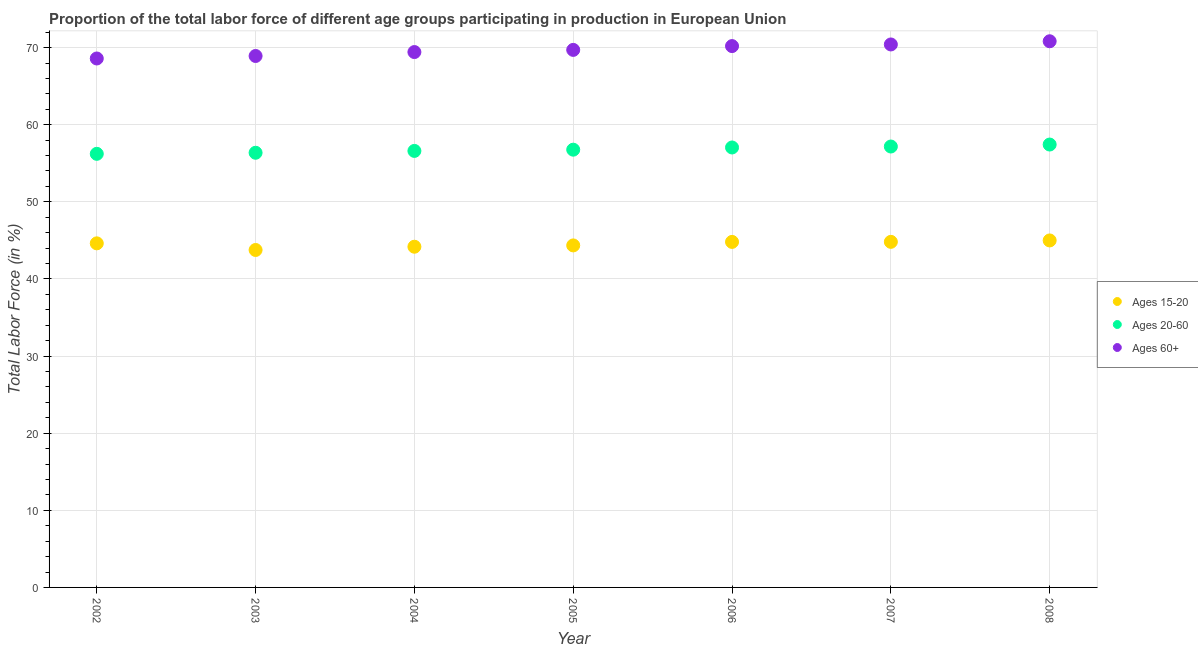What is the percentage of labor force above age 60 in 2003?
Your answer should be compact. 68.91. Across all years, what is the maximum percentage of labor force within the age group 20-60?
Your response must be concise. 57.43. Across all years, what is the minimum percentage of labor force within the age group 20-60?
Your answer should be compact. 56.23. What is the total percentage of labor force within the age group 15-20 in the graph?
Make the answer very short. 311.52. What is the difference between the percentage of labor force above age 60 in 2006 and that in 2008?
Your answer should be compact. -0.63. What is the difference between the percentage of labor force above age 60 in 2008 and the percentage of labor force within the age group 15-20 in 2004?
Offer a terse response. 26.64. What is the average percentage of labor force above age 60 per year?
Offer a terse response. 69.72. In the year 2003, what is the difference between the percentage of labor force above age 60 and percentage of labor force within the age group 15-20?
Your response must be concise. 25.16. In how many years, is the percentage of labor force within the age group 20-60 greater than 22 %?
Your answer should be very brief. 7. What is the ratio of the percentage of labor force within the age group 20-60 in 2002 to that in 2006?
Your answer should be very brief. 0.99. Is the difference between the percentage of labor force within the age group 15-20 in 2002 and 2004 greater than the difference between the percentage of labor force above age 60 in 2002 and 2004?
Provide a short and direct response. Yes. What is the difference between the highest and the second highest percentage of labor force above age 60?
Give a very brief answer. 0.41. What is the difference between the highest and the lowest percentage of labor force within the age group 20-60?
Your answer should be compact. 1.21. In how many years, is the percentage of labor force within the age group 15-20 greater than the average percentage of labor force within the age group 15-20 taken over all years?
Your answer should be compact. 4. Is the sum of the percentage of labor force above age 60 in 2007 and 2008 greater than the maximum percentage of labor force within the age group 15-20 across all years?
Make the answer very short. Yes. Does the percentage of labor force above age 60 monotonically increase over the years?
Give a very brief answer. Yes. Are the values on the major ticks of Y-axis written in scientific E-notation?
Offer a very short reply. No. What is the title of the graph?
Make the answer very short. Proportion of the total labor force of different age groups participating in production in European Union. Does "Negligence towards kids" appear as one of the legend labels in the graph?
Make the answer very short. No. What is the label or title of the Y-axis?
Give a very brief answer. Total Labor Force (in %). What is the Total Labor Force (in %) in Ages 15-20 in 2002?
Your answer should be very brief. 44.62. What is the Total Labor Force (in %) in Ages 20-60 in 2002?
Your answer should be very brief. 56.23. What is the Total Labor Force (in %) of Ages 60+ in 2002?
Your answer should be compact. 68.59. What is the Total Labor Force (in %) of Ages 15-20 in 2003?
Offer a very short reply. 43.76. What is the Total Labor Force (in %) of Ages 20-60 in 2003?
Provide a short and direct response. 56.36. What is the Total Labor Force (in %) of Ages 60+ in 2003?
Provide a short and direct response. 68.91. What is the Total Labor Force (in %) in Ages 15-20 in 2004?
Provide a short and direct response. 44.18. What is the Total Labor Force (in %) of Ages 20-60 in 2004?
Your answer should be compact. 56.6. What is the Total Labor Force (in %) of Ages 60+ in 2004?
Your response must be concise. 69.42. What is the Total Labor Force (in %) in Ages 15-20 in 2005?
Your response must be concise. 44.35. What is the Total Labor Force (in %) in Ages 20-60 in 2005?
Keep it short and to the point. 56.76. What is the Total Labor Force (in %) in Ages 60+ in 2005?
Ensure brevity in your answer.  69.7. What is the Total Labor Force (in %) in Ages 15-20 in 2006?
Provide a succinct answer. 44.81. What is the Total Labor Force (in %) in Ages 20-60 in 2006?
Your response must be concise. 57.05. What is the Total Labor Force (in %) in Ages 60+ in 2006?
Your answer should be very brief. 70.2. What is the Total Labor Force (in %) in Ages 15-20 in 2007?
Keep it short and to the point. 44.81. What is the Total Labor Force (in %) in Ages 20-60 in 2007?
Provide a short and direct response. 57.17. What is the Total Labor Force (in %) in Ages 60+ in 2007?
Make the answer very short. 70.41. What is the Total Labor Force (in %) in Ages 15-20 in 2008?
Your answer should be compact. 44.99. What is the Total Labor Force (in %) of Ages 20-60 in 2008?
Keep it short and to the point. 57.43. What is the Total Labor Force (in %) in Ages 60+ in 2008?
Ensure brevity in your answer.  70.82. Across all years, what is the maximum Total Labor Force (in %) in Ages 15-20?
Give a very brief answer. 44.99. Across all years, what is the maximum Total Labor Force (in %) in Ages 20-60?
Make the answer very short. 57.43. Across all years, what is the maximum Total Labor Force (in %) in Ages 60+?
Give a very brief answer. 70.82. Across all years, what is the minimum Total Labor Force (in %) of Ages 15-20?
Make the answer very short. 43.76. Across all years, what is the minimum Total Labor Force (in %) of Ages 20-60?
Your response must be concise. 56.23. Across all years, what is the minimum Total Labor Force (in %) in Ages 60+?
Provide a short and direct response. 68.59. What is the total Total Labor Force (in %) of Ages 15-20 in the graph?
Your answer should be very brief. 311.52. What is the total Total Labor Force (in %) of Ages 20-60 in the graph?
Offer a terse response. 397.61. What is the total Total Labor Force (in %) of Ages 60+ in the graph?
Your answer should be very brief. 488.06. What is the difference between the Total Labor Force (in %) of Ages 15-20 in 2002 and that in 2003?
Keep it short and to the point. 0.86. What is the difference between the Total Labor Force (in %) in Ages 20-60 in 2002 and that in 2003?
Your response must be concise. -0.14. What is the difference between the Total Labor Force (in %) in Ages 60+ in 2002 and that in 2003?
Offer a terse response. -0.32. What is the difference between the Total Labor Force (in %) of Ages 15-20 in 2002 and that in 2004?
Provide a succinct answer. 0.44. What is the difference between the Total Labor Force (in %) in Ages 20-60 in 2002 and that in 2004?
Offer a very short reply. -0.38. What is the difference between the Total Labor Force (in %) in Ages 60+ in 2002 and that in 2004?
Make the answer very short. -0.83. What is the difference between the Total Labor Force (in %) of Ages 15-20 in 2002 and that in 2005?
Provide a short and direct response. 0.27. What is the difference between the Total Labor Force (in %) of Ages 20-60 in 2002 and that in 2005?
Make the answer very short. -0.54. What is the difference between the Total Labor Force (in %) of Ages 60+ in 2002 and that in 2005?
Make the answer very short. -1.11. What is the difference between the Total Labor Force (in %) of Ages 15-20 in 2002 and that in 2006?
Keep it short and to the point. -0.19. What is the difference between the Total Labor Force (in %) of Ages 20-60 in 2002 and that in 2006?
Give a very brief answer. -0.82. What is the difference between the Total Labor Force (in %) in Ages 60+ in 2002 and that in 2006?
Ensure brevity in your answer.  -1.61. What is the difference between the Total Labor Force (in %) of Ages 15-20 in 2002 and that in 2007?
Your answer should be compact. -0.19. What is the difference between the Total Labor Force (in %) of Ages 20-60 in 2002 and that in 2007?
Make the answer very short. -0.95. What is the difference between the Total Labor Force (in %) of Ages 60+ in 2002 and that in 2007?
Your response must be concise. -1.82. What is the difference between the Total Labor Force (in %) in Ages 15-20 in 2002 and that in 2008?
Your answer should be compact. -0.38. What is the difference between the Total Labor Force (in %) in Ages 20-60 in 2002 and that in 2008?
Provide a succinct answer. -1.21. What is the difference between the Total Labor Force (in %) of Ages 60+ in 2002 and that in 2008?
Give a very brief answer. -2.23. What is the difference between the Total Labor Force (in %) in Ages 15-20 in 2003 and that in 2004?
Ensure brevity in your answer.  -0.42. What is the difference between the Total Labor Force (in %) of Ages 20-60 in 2003 and that in 2004?
Ensure brevity in your answer.  -0.24. What is the difference between the Total Labor Force (in %) in Ages 60+ in 2003 and that in 2004?
Give a very brief answer. -0.51. What is the difference between the Total Labor Force (in %) in Ages 15-20 in 2003 and that in 2005?
Make the answer very short. -0.59. What is the difference between the Total Labor Force (in %) of Ages 20-60 in 2003 and that in 2005?
Your answer should be compact. -0.4. What is the difference between the Total Labor Force (in %) of Ages 60+ in 2003 and that in 2005?
Ensure brevity in your answer.  -0.79. What is the difference between the Total Labor Force (in %) of Ages 15-20 in 2003 and that in 2006?
Give a very brief answer. -1.05. What is the difference between the Total Labor Force (in %) of Ages 20-60 in 2003 and that in 2006?
Make the answer very short. -0.68. What is the difference between the Total Labor Force (in %) in Ages 60+ in 2003 and that in 2006?
Make the answer very short. -1.28. What is the difference between the Total Labor Force (in %) in Ages 15-20 in 2003 and that in 2007?
Provide a short and direct response. -1.05. What is the difference between the Total Labor Force (in %) in Ages 20-60 in 2003 and that in 2007?
Offer a very short reply. -0.81. What is the difference between the Total Labor Force (in %) in Ages 60+ in 2003 and that in 2007?
Provide a short and direct response. -1.5. What is the difference between the Total Labor Force (in %) in Ages 15-20 in 2003 and that in 2008?
Offer a terse response. -1.24. What is the difference between the Total Labor Force (in %) in Ages 20-60 in 2003 and that in 2008?
Provide a short and direct response. -1.07. What is the difference between the Total Labor Force (in %) of Ages 60+ in 2003 and that in 2008?
Offer a terse response. -1.91. What is the difference between the Total Labor Force (in %) in Ages 15-20 in 2004 and that in 2005?
Provide a short and direct response. -0.17. What is the difference between the Total Labor Force (in %) in Ages 20-60 in 2004 and that in 2005?
Your answer should be very brief. -0.16. What is the difference between the Total Labor Force (in %) in Ages 60+ in 2004 and that in 2005?
Give a very brief answer. -0.28. What is the difference between the Total Labor Force (in %) in Ages 15-20 in 2004 and that in 2006?
Your answer should be compact. -0.63. What is the difference between the Total Labor Force (in %) of Ages 20-60 in 2004 and that in 2006?
Keep it short and to the point. -0.45. What is the difference between the Total Labor Force (in %) of Ages 60+ in 2004 and that in 2006?
Offer a terse response. -0.77. What is the difference between the Total Labor Force (in %) in Ages 15-20 in 2004 and that in 2007?
Give a very brief answer. -0.63. What is the difference between the Total Labor Force (in %) in Ages 20-60 in 2004 and that in 2007?
Offer a terse response. -0.57. What is the difference between the Total Labor Force (in %) in Ages 60+ in 2004 and that in 2007?
Your response must be concise. -0.99. What is the difference between the Total Labor Force (in %) in Ages 15-20 in 2004 and that in 2008?
Give a very brief answer. -0.82. What is the difference between the Total Labor Force (in %) in Ages 20-60 in 2004 and that in 2008?
Make the answer very short. -0.83. What is the difference between the Total Labor Force (in %) in Ages 60+ in 2004 and that in 2008?
Provide a succinct answer. -1.4. What is the difference between the Total Labor Force (in %) in Ages 15-20 in 2005 and that in 2006?
Offer a terse response. -0.45. What is the difference between the Total Labor Force (in %) of Ages 20-60 in 2005 and that in 2006?
Your answer should be compact. -0.29. What is the difference between the Total Labor Force (in %) of Ages 60+ in 2005 and that in 2006?
Ensure brevity in your answer.  -0.49. What is the difference between the Total Labor Force (in %) of Ages 15-20 in 2005 and that in 2007?
Make the answer very short. -0.46. What is the difference between the Total Labor Force (in %) of Ages 20-60 in 2005 and that in 2007?
Keep it short and to the point. -0.41. What is the difference between the Total Labor Force (in %) in Ages 60+ in 2005 and that in 2007?
Provide a succinct answer. -0.71. What is the difference between the Total Labor Force (in %) in Ages 15-20 in 2005 and that in 2008?
Provide a short and direct response. -0.64. What is the difference between the Total Labor Force (in %) of Ages 20-60 in 2005 and that in 2008?
Offer a very short reply. -0.67. What is the difference between the Total Labor Force (in %) of Ages 60+ in 2005 and that in 2008?
Your response must be concise. -1.12. What is the difference between the Total Labor Force (in %) of Ages 15-20 in 2006 and that in 2007?
Offer a terse response. -0.01. What is the difference between the Total Labor Force (in %) in Ages 20-60 in 2006 and that in 2007?
Give a very brief answer. -0.12. What is the difference between the Total Labor Force (in %) of Ages 60+ in 2006 and that in 2007?
Offer a terse response. -0.21. What is the difference between the Total Labor Force (in %) in Ages 15-20 in 2006 and that in 2008?
Your response must be concise. -0.19. What is the difference between the Total Labor Force (in %) in Ages 20-60 in 2006 and that in 2008?
Offer a very short reply. -0.38. What is the difference between the Total Labor Force (in %) of Ages 60+ in 2006 and that in 2008?
Your response must be concise. -0.63. What is the difference between the Total Labor Force (in %) of Ages 15-20 in 2007 and that in 2008?
Your answer should be very brief. -0.18. What is the difference between the Total Labor Force (in %) in Ages 20-60 in 2007 and that in 2008?
Provide a succinct answer. -0.26. What is the difference between the Total Labor Force (in %) in Ages 60+ in 2007 and that in 2008?
Provide a succinct answer. -0.41. What is the difference between the Total Labor Force (in %) in Ages 15-20 in 2002 and the Total Labor Force (in %) in Ages 20-60 in 2003?
Provide a short and direct response. -11.75. What is the difference between the Total Labor Force (in %) in Ages 15-20 in 2002 and the Total Labor Force (in %) in Ages 60+ in 2003?
Ensure brevity in your answer.  -24.3. What is the difference between the Total Labor Force (in %) of Ages 20-60 in 2002 and the Total Labor Force (in %) of Ages 60+ in 2003?
Keep it short and to the point. -12.69. What is the difference between the Total Labor Force (in %) in Ages 15-20 in 2002 and the Total Labor Force (in %) in Ages 20-60 in 2004?
Your answer should be compact. -11.99. What is the difference between the Total Labor Force (in %) in Ages 15-20 in 2002 and the Total Labor Force (in %) in Ages 60+ in 2004?
Offer a very short reply. -24.8. What is the difference between the Total Labor Force (in %) of Ages 20-60 in 2002 and the Total Labor Force (in %) of Ages 60+ in 2004?
Make the answer very short. -13.2. What is the difference between the Total Labor Force (in %) of Ages 15-20 in 2002 and the Total Labor Force (in %) of Ages 20-60 in 2005?
Provide a succinct answer. -12.15. What is the difference between the Total Labor Force (in %) in Ages 15-20 in 2002 and the Total Labor Force (in %) in Ages 60+ in 2005?
Provide a succinct answer. -25.09. What is the difference between the Total Labor Force (in %) of Ages 20-60 in 2002 and the Total Labor Force (in %) of Ages 60+ in 2005?
Offer a terse response. -13.48. What is the difference between the Total Labor Force (in %) of Ages 15-20 in 2002 and the Total Labor Force (in %) of Ages 20-60 in 2006?
Give a very brief answer. -12.43. What is the difference between the Total Labor Force (in %) of Ages 15-20 in 2002 and the Total Labor Force (in %) of Ages 60+ in 2006?
Give a very brief answer. -25.58. What is the difference between the Total Labor Force (in %) of Ages 20-60 in 2002 and the Total Labor Force (in %) of Ages 60+ in 2006?
Make the answer very short. -13.97. What is the difference between the Total Labor Force (in %) in Ages 15-20 in 2002 and the Total Labor Force (in %) in Ages 20-60 in 2007?
Ensure brevity in your answer.  -12.56. What is the difference between the Total Labor Force (in %) in Ages 15-20 in 2002 and the Total Labor Force (in %) in Ages 60+ in 2007?
Offer a terse response. -25.79. What is the difference between the Total Labor Force (in %) in Ages 20-60 in 2002 and the Total Labor Force (in %) in Ages 60+ in 2007?
Keep it short and to the point. -14.18. What is the difference between the Total Labor Force (in %) in Ages 15-20 in 2002 and the Total Labor Force (in %) in Ages 20-60 in 2008?
Your answer should be very brief. -12.81. What is the difference between the Total Labor Force (in %) in Ages 15-20 in 2002 and the Total Labor Force (in %) in Ages 60+ in 2008?
Your answer should be compact. -26.21. What is the difference between the Total Labor Force (in %) in Ages 20-60 in 2002 and the Total Labor Force (in %) in Ages 60+ in 2008?
Offer a very short reply. -14.6. What is the difference between the Total Labor Force (in %) of Ages 15-20 in 2003 and the Total Labor Force (in %) of Ages 20-60 in 2004?
Your answer should be compact. -12.85. What is the difference between the Total Labor Force (in %) in Ages 15-20 in 2003 and the Total Labor Force (in %) in Ages 60+ in 2004?
Ensure brevity in your answer.  -25.67. What is the difference between the Total Labor Force (in %) in Ages 20-60 in 2003 and the Total Labor Force (in %) in Ages 60+ in 2004?
Ensure brevity in your answer.  -13.06. What is the difference between the Total Labor Force (in %) in Ages 15-20 in 2003 and the Total Labor Force (in %) in Ages 20-60 in 2005?
Your answer should be very brief. -13.01. What is the difference between the Total Labor Force (in %) in Ages 15-20 in 2003 and the Total Labor Force (in %) in Ages 60+ in 2005?
Your answer should be very brief. -25.95. What is the difference between the Total Labor Force (in %) in Ages 20-60 in 2003 and the Total Labor Force (in %) in Ages 60+ in 2005?
Keep it short and to the point. -13.34. What is the difference between the Total Labor Force (in %) in Ages 15-20 in 2003 and the Total Labor Force (in %) in Ages 20-60 in 2006?
Keep it short and to the point. -13.29. What is the difference between the Total Labor Force (in %) in Ages 15-20 in 2003 and the Total Labor Force (in %) in Ages 60+ in 2006?
Provide a succinct answer. -26.44. What is the difference between the Total Labor Force (in %) of Ages 20-60 in 2003 and the Total Labor Force (in %) of Ages 60+ in 2006?
Provide a succinct answer. -13.83. What is the difference between the Total Labor Force (in %) in Ages 15-20 in 2003 and the Total Labor Force (in %) in Ages 20-60 in 2007?
Your answer should be compact. -13.42. What is the difference between the Total Labor Force (in %) of Ages 15-20 in 2003 and the Total Labor Force (in %) of Ages 60+ in 2007?
Give a very brief answer. -26.65. What is the difference between the Total Labor Force (in %) of Ages 20-60 in 2003 and the Total Labor Force (in %) of Ages 60+ in 2007?
Your answer should be compact. -14.04. What is the difference between the Total Labor Force (in %) in Ages 15-20 in 2003 and the Total Labor Force (in %) in Ages 20-60 in 2008?
Provide a short and direct response. -13.67. What is the difference between the Total Labor Force (in %) in Ages 15-20 in 2003 and the Total Labor Force (in %) in Ages 60+ in 2008?
Offer a terse response. -27.07. What is the difference between the Total Labor Force (in %) in Ages 20-60 in 2003 and the Total Labor Force (in %) in Ages 60+ in 2008?
Your answer should be very brief. -14.46. What is the difference between the Total Labor Force (in %) of Ages 15-20 in 2004 and the Total Labor Force (in %) of Ages 20-60 in 2005?
Ensure brevity in your answer.  -12.58. What is the difference between the Total Labor Force (in %) in Ages 15-20 in 2004 and the Total Labor Force (in %) in Ages 60+ in 2005?
Your response must be concise. -25.52. What is the difference between the Total Labor Force (in %) of Ages 20-60 in 2004 and the Total Labor Force (in %) of Ages 60+ in 2005?
Provide a short and direct response. -13.1. What is the difference between the Total Labor Force (in %) of Ages 15-20 in 2004 and the Total Labor Force (in %) of Ages 20-60 in 2006?
Provide a short and direct response. -12.87. What is the difference between the Total Labor Force (in %) of Ages 15-20 in 2004 and the Total Labor Force (in %) of Ages 60+ in 2006?
Provide a short and direct response. -26.02. What is the difference between the Total Labor Force (in %) of Ages 20-60 in 2004 and the Total Labor Force (in %) of Ages 60+ in 2006?
Your response must be concise. -13.59. What is the difference between the Total Labor Force (in %) of Ages 15-20 in 2004 and the Total Labor Force (in %) of Ages 20-60 in 2007?
Offer a terse response. -12.99. What is the difference between the Total Labor Force (in %) in Ages 15-20 in 2004 and the Total Labor Force (in %) in Ages 60+ in 2007?
Your answer should be very brief. -26.23. What is the difference between the Total Labor Force (in %) of Ages 20-60 in 2004 and the Total Labor Force (in %) of Ages 60+ in 2007?
Keep it short and to the point. -13.81. What is the difference between the Total Labor Force (in %) of Ages 15-20 in 2004 and the Total Labor Force (in %) of Ages 20-60 in 2008?
Offer a terse response. -13.25. What is the difference between the Total Labor Force (in %) of Ages 15-20 in 2004 and the Total Labor Force (in %) of Ages 60+ in 2008?
Offer a terse response. -26.64. What is the difference between the Total Labor Force (in %) in Ages 20-60 in 2004 and the Total Labor Force (in %) in Ages 60+ in 2008?
Your response must be concise. -14.22. What is the difference between the Total Labor Force (in %) in Ages 15-20 in 2005 and the Total Labor Force (in %) in Ages 20-60 in 2006?
Your answer should be compact. -12.7. What is the difference between the Total Labor Force (in %) in Ages 15-20 in 2005 and the Total Labor Force (in %) in Ages 60+ in 2006?
Make the answer very short. -25.85. What is the difference between the Total Labor Force (in %) of Ages 20-60 in 2005 and the Total Labor Force (in %) of Ages 60+ in 2006?
Provide a succinct answer. -13.43. What is the difference between the Total Labor Force (in %) in Ages 15-20 in 2005 and the Total Labor Force (in %) in Ages 20-60 in 2007?
Your answer should be compact. -12.82. What is the difference between the Total Labor Force (in %) in Ages 15-20 in 2005 and the Total Labor Force (in %) in Ages 60+ in 2007?
Your answer should be very brief. -26.06. What is the difference between the Total Labor Force (in %) of Ages 20-60 in 2005 and the Total Labor Force (in %) of Ages 60+ in 2007?
Your answer should be compact. -13.64. What is the difference between the Total Labor Force (in %) in Ages 15-20 in 2005 and the Total Labor Force (in %) in Ages 20-60 in 2008?
Provide a succinct answer. -13.08. What is the difference between the Total Labor Force (in %) in Ages 15-20 in 2005 and the Total Labor Force (in %) in Ages 60+ in 2008?
Give a very brief answer. -26.47. What is the difference between the Total Labor Force (in %) in Ages 20-60 in 2005 and the Total Labor Force (in %) in Ages 60+ in 2008?
Provide a short and direct response. -14.06. What is the difference between the Total Labor Force (in %) of Ages 15-20 in 2006 and the Total Labor Force (in %) of Ages 20-60 in 2007?
Your answer should be compact. -12.37. What is the difference between the Total Labor Force (in %) of Ages 15-20 in 2006 and the Total Labor Force (in %) of Ages 60+ in 2007?
Offer a terse response. -25.6. What is the difference between the Total Labor Force (in %) of Ages 20-60 in 2006 and the Total Labor Force (in %) of Ages 60+ in 2007?
Provide a succinct answer. -13.36. What is the difference between the Total Labor Force (in %) of Ages 15-20 in 2006 and the Total Labor Force (in %) of Ages 20-60 in 2008?
Your answer should be very brief. -12.63. What is the difference between the Total Labor Force (in %) in Ages 15-20 in 2006 and the Total Labor Force (in %) in Ages 60+ in 2008?
Ensure brevity in your answer.  -26.02. What is the difference between the Total Labor Force (in %) of Ages 20-60 in 2006 and the Total Labor Force (in %) of Ages 60+ in 2008?
Give a very brief answer. -13.77. What is the difference between the Total Labor Force (in %) of Ages 15-20 in 2007 and the Total Labor Force (in %) of Ages 20-60 in 2008?
Give a very brief answer. -12.62. What is the difference between the Total Labor Force (in %) of Ages 15-20 in 2007 and the Total Labor Force (in %) of Ages 60+ in 2008?
Provide a short and direct response. -26.01. What is the difference between the Total Labor Force (in %) of Ages 20-60 in 2007 and the Total Labor Force (in %) of Ages 60+ in 2008?
Make the answer very short. -13.65. What is the average Total Labor Force (in %) in Ages 15-20 per year?
Make the answer very short. 44.5. What is the average Total Labor Force (in %) of Ages 20-60 per year?
Keep it short and to the point. 56.8. What is the average Total Labor Force (in %) of Ages 60+ per year?
Your answer should be very brief. 69.72. In the year 2002, what is the difference between the Total Labor Force (in %) of Ages 15-20 and Total Labor Force (in %) of Ages 20-60?
Your response must be concise. -11.61. In the year 2002, what is the difference between the Total Labor Force (in %) of Ages 15-20 and Total Labor Force (in %) of Ages 60+?
Your answer should be very brief. -23.97. In the year 2002, what is the difference between the Total Labor Force (in %) in Ages 20-60 and Total Labor Force (in %) in Ages 60+?
Make the answer very short. -12.36. In the year 2003, what is the difference between the Total Labor Force (in %) of Ages 15-20 and Total Labor Force (in %) of Ages 20-60?
Give a very brief answer. -12.61. In the year 2003, what is the difference between the Total Labor Force (in %) in Ages 15-20 and Total Labor Force (in %) in Ages 60+?
Provide a short and direct response. -25.16. In the year 2003, what is the difference between the Total Labor Force (in %) of Ages 20-60 and Total Labor Force (in %) of Ages 60+?
Provide a succinct answer. -12.55. In the year 2004, what is the difference between the Total Labor Force (in %) in Ages 15-20 and Total Labor Force (in %) in Ages 20-60?
Keep it short and to the point. -12.42. In the year 2004, what is the difference between the Total Labor Force (in %) in Ages 15-20 and Total Labor Force (in %) in Ages 60+?
Make the answer very short. -25.24. In the year 2004, what is the difference between the Total Labor Force (in %) of Ages 20-60 and Total Labor Force (in %) of Ages 60+?
Ensure brevity in your answer.  -12.82. In the year 2005, what is the difference between the Total Labor Force (in %) of Ages 15-20 and Total Labor Force (in %) of Ages 20-60?
Your answer should be compact. -12.41. In the year 2005, what is the difference between the Total Labor Force (in %) in Ages 15-20 and Total Labor Force (in %) in Ages 60+?
Keep it short and to the point. -25.35. In the year 2005, what is the difference between the Total Labor Force (in %) in Ages 20-60 and Total Labor Force (in %) in Ages 60+?
Offer a terse response. -12.94. In the year 2006, what is the difference between the Total Labor Force (in %) in Ages 15-20 and Total Labor Force (in %) in Ages 20-60?
Provide a short and direct response. -12.24. In the year 2006, what is the difference between the Total Labor Force (in %) in Ages 15-20 and Total Labor Force (in %) in Ages 60+?
Keep it short and to the point. -25.39. In the year 2006, what is the difference between the Total Labor Force (in %) of Ages 20-60 and Total Labor Force (in %) of Ages 60+?
Provide a short and direct response. -13.15. In the year 2007, what is the difference between the Total Labor Force (in %) of Ages 15-20 and Total Labor Force (in %) of Ages 20-60?
Offer a terse response. -12.36. In the year 2007, what is the difference between the Total Labor Force (in %) of Ages 15-20 and Total Labor Force (in %) of Ages 60+?
Provide a succinct answer. -25.6. In the year 2007, what is the difference between the Total Labor Force (in %) in Ages 20-60 and Total Labor Force (in %) in Ages 60+?
Provide a succinct answer. -13.24. In the year 2008, what is the difference between the Total Labor Force (in %) in Ages 15-20 and Total Labor Force (in %) in Ages 20-60?
Provide a short and direct response. -12.44. In the year 2008, what is the difference between the Total Labor Force (in %) of Ages 15-20 and Total Labor Force (in %) of Ages 60+?
Your answer should be very brief. -25.83. In the year 2008, what is the difference between the Total Labor Force (in %) of Ages 20-60 and Total Labor Force (in %) of Ages 60+?
Offer a terse response. -13.39. What is the ratio of the Total Labor Force (in %) in Ages 15-20 in 2002 to that in 2003?
Ensure brevity in your answer.  1.02. What is the ratio of the Total Labor Force (in %) in Ages 20-60 in 2002 to that in 2003?
Offer a terse response. 1. What is the ratio of the Total Labor Force (in %) in Ages 60+ in 2002 to that in 2003?
Your answer should be very brief. 1. What is the ratio of the Total Labor Force (in %) of Ages 15-20 in 2002 to that in 2004?
Provide a succinct answer. 1.01. What is the ratio of the Total Labor Force (in %) of Ages 15-20 in 2002 to that in 2005?
Provide a short and direct response. 1.01. What is the ratio of the Total Labor Force (in %) in Ages 20-60 in 2002 to that in 2005?
Provide a succinct answer. 0.99. What is the ratio of the Total Labor Force (in %) of Ages 60+ in 2002 to that in 2005?
Your answer should be compact. 0.98. What is the ratio of the Total Labor Force (in %) in Ages 15-20 in 2002 to that in 2006?
Your answer should be compact. 1. What is the ratio of the Total Labor Force (in %) of Ages 20-60 in 2002 to that in 2006?
Ensure brevity in your answer.  0.99. What is the ratio of the Total Labor Force (in %) in Ages 60+ in 2002 to that in 2006?
Your response must be concise. 0.98. What is the ratio of the Total Labor Force (in %) of Ages 20-60 in 2002 to that in 2007?
Provide a short and direct response. 0.98. What is the ratio of the Total Labor Force (in %) of Ages 60+ in 2002 to that in 2007?
Provide a short and direct response. 0.97. What is the ratio of the Total Labor Force (in %) of Ages 15-20 in 2002 to that in 2008?
Provide a succinct answer. 0.99. What is the ratio of the Total Labor Force (in %) of Ages 20-60 in 2002 to that in 2008?
Make the answer very short. 0.98. What is the ratio of the Total Labor Force (in %) in Ages 60+ in 2002 to that in 2008?
Offer a very short reply. 0.97. What is the ratio of the Total Labor Force (in %) in Ages 15-20 in 2003 to that in 2004?
Offer a very short reply. 0.99. What is the ratio of the Total Labor Force (in %) in Ages 15-20 in 2003 to that in 2005?
Your response must be concise. 0.99. What is the ratio of the Total Labor Force (in %) in Ages 60+ in 2003 to that in 2005?
Give a very brief answer. 0.99. What is the ratio of the Total Labor Force (in %) of Ages 15-20 in 2003 to that in 2006?
Your answer should be compact. 0.98. What is the ratio of the Total Labor Force (in %) in Ages 60+ in 2003 to that in 2006?
Provide a succinct answer. 0.98. What is the ratio of the Total Labor Force (in %) of Ages 15-20 in 2003 to that in 2007?
Your answer should be very brief. 0.98. What is the ratio of the Total Labor Force (in %) of Ages 20-60 in 2003 to that in 2007?
Offer a very short reply. 0.99. What is the ratio of the Total Labor Force (in %) in Ages 60+ in 2003 to that in 2007?
Offer a terse response. 0.98. What is the ratio of the Total Labor Force (in %) in Ages 15-20 in 2003 to that in 2008?
Offer a very short reply. 0.97. What is the ratio of the Total Labor Force (in %) of Ages 20-60 in 2003 to that in 2008?
Your answer should be compact. 0.98. What is the ratio of the Total Labor Force (in %) in Ages 60+ in 2003 to that in 2008?
Give a very brief answer. 0.97. What is the ratio of the Total Labor Force (in %) of Ages 15-20 in 2004 to that in 2005?
Provide a short and direct response. 1. What is the ratio of the Total Labor Force (in %) in Ages 20-60 in 2004 to that in 2006?
Provide a succinct answer. 0.99. What is the ratio of the Total Labor Force (in %) of Ages 60+ in 2004 to that in 2006?
Your answer should be compact. 0.99. What is the ratio of the Total Labor Force (in %) of Ages 15-20 in 2004 to that in 2007?
Your response must be concise. 0.99. What is the ratio of the Total Labor Force (in %) of Ages 20-60 in 2004 to that in 2007?
Offer a very short reply. 0.99. What is the ratio of the Total Labor Force (in %) of Ages 15-20 in 2004 to that in 2008?
Provide a succinct answer. 0.98. What is the ratio of the Total Labor Force (in %) of Ages 20-60 in 2004 to that in 2008?
Provide a short and direct response. 0.99. What is the ratio of the Total Labor Force (in %) of Ages 60+ in 2004 to that in 2008?
Offer a very short reply. 0.98. What is the ratio of the Total Labor Force (in %) of Ages 60+ in 2005 to that in 2006?
Your answer should be very brief. 0.99. What is the ratio of the Total Labor Force (in %) of Ages 15-20 in 2005 to that in 2008?
Your answer should be very brief. 0.99. What is the ratio of the Total Labor Force (in %) of Ages 20-60 in 2005 to that in 2008?
Give a very brief answer. 0.99. What is the ratio of the Total Labor Force (in %) in Ages 60+ in 2005 to that in 2008?
Your answer should be very brief. 0.98. What is the ratio of the Total Labor Force (in %) of Ages 20-60 in 2006 to that in 2007?
Your answer should be very brief. 1. What is the ratio of the Total Labor Force (in %) of Ages 60+ in 2006 to that in 2007?
Offer a very short reply. 1. What is the ratio of the Total Labor Force (in %) in Ages 60+ in 2006 to that in 2008?
Keep it short and to the point. 0.99. What is the ratio of the Total Labor Force (in %) of Ages 15-20 in 2007 to that in 2008?
Offer a terse response. 1. What is the ratio of the Total Labor Force (in %) of Ages 20-60 in 2007 to that in 2008?
Ensure brevity in your answer.  1. What is the ratio of the Total Labor Force (in %) of Ages 60+ in 2007 to that in 2008?
Provide a short and direct response. 0.99. What is the difference between the highest and the second highest Total Labor Force (in %) of Ages 15-20?
Keep it short and to the point. 0.18. What is the difference between the highest and the second highest Total Labor Force (in %) of Ages 20-60?
Keep it short and to the point. 0.26. What is the difference between the highest and the second highest Total Labor Force (in %) in Ages 60+?
Provide a succinct answer. 0.41. What is the difference between the highest and the lowest Total Labor Force (in %) in Ages 15-20?
Your answer should be very brief. 1.24. What is the difference between the highest and the lowest Total Labor Force (in %) of Ages 20-60?
Provide a short and direct response. 1.21. What is the difference between the highest and the lowest Total Labor Force (in %) in Ages 60+?
Ensure brevity in your answer.  2.23. 